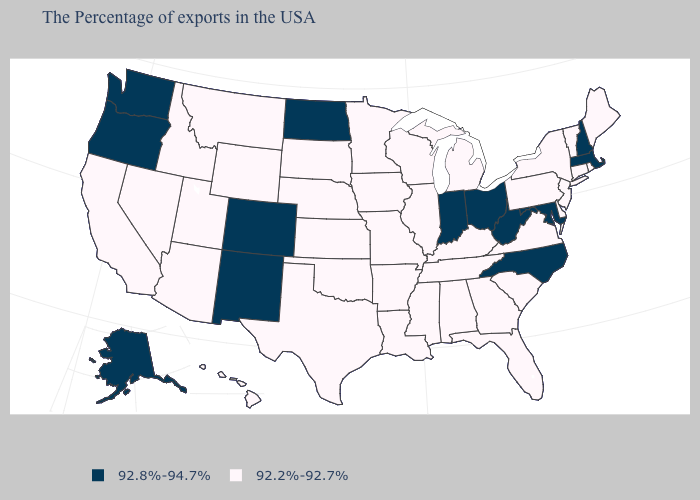What is the lowest value in the West?
Keep it brief. 92.2%-92.7%. Name the states that have a value in the range 92.8%-94.7%?
Answer briefly. Massachusetts, New Hampshire, Maryland, North Carolina, West Virginia, Ohio, Indiana, North Dakota, Colorado, New Mexico, Washington, Oregon, Alaska. Does the first symbol in the legend represent the smallest category?
Answer briefly. No. What is the value of Indiana?
Answer briefly. 92.8%-94.7%. What is the value of Arizona?
Be succinct. 92.2%-92.7%. Name the states that have a value in the range 92.8%-94.7%?
Answer briefly. Massachusetts, New Hampshire, Maryland, North Carolina, West Virginia, Ohio, Indiana, North Dakota, Colorado, New Mexico, Washington, Oregon, Alaska. Among the states that border Virginia , does West Virginia have the highest value?
Give a very brief answer. Yes. Which states hav the highest value in the West?
Write a very short answer. Colorado, New Mexico, Washington, Oregon, Alaska. Which states have the highest value in the USA?
Short answer required. Massachusetts, New Hampshire, Maryland, North Carolina, West Virginia, Ohio, Indiana, North Dakota, Colorado, New Mexico, Washington, Oregon, Alaska. What is the value of Georgia?
Write a very short answer. 92.2%-92.7%. Does Maryland have the highest value in the USA?
Keep it brief. Yes. Among the states that border Vermont , does Massachusetts have the lowest value?
Be succinct. No. Which states have the highest value in the USA?
Concise answer only. Massachusetts, New Hampshire, Maryland, North Carolina, West Virginia, Ohio, Indiana, North Dakota, Colorado, New Mexico, Washington, Oregon, Alaska. What is the lowest value in the Northeast?
Be succinct. 92.2%-92.7%. Does New York have the same value as Nevada?
Concise answer only. Yes. 